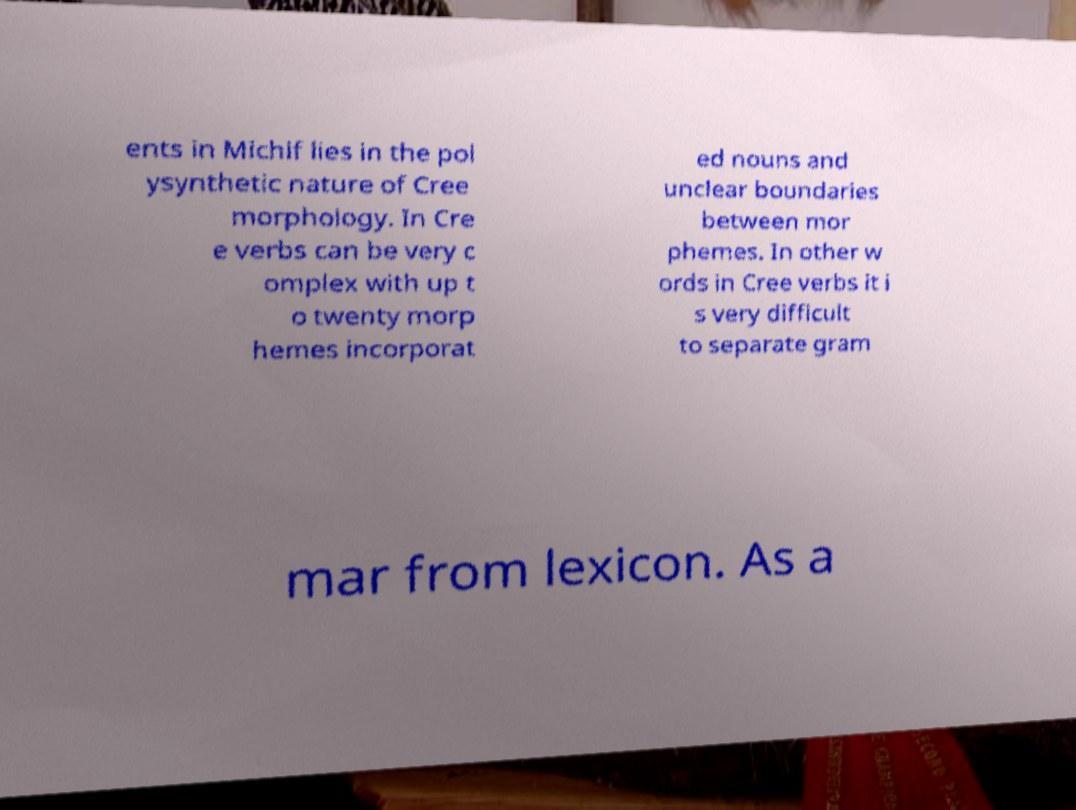Could you extract and type out the text from this image? ents in Michif lies in the pol ysynthetic nature of Cree morphology. In Cre e verbs can be very c omplex with up t o twenty morp hemes incorporat ed nouns and unclear boundaries between mor phemes. In other w ords in Cree verbs it i s very difficult to separate gram mar from lexicon. As a 